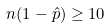<formula> <loc_0><loc_0><loc_500><loc_500>n ( 1 - { \hat { p } } ) \geq 1 0</formula> 